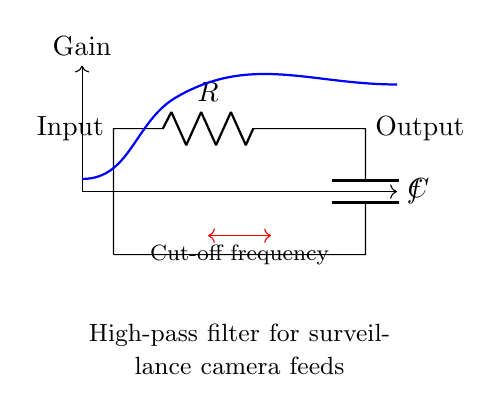What type of filter is represented in the circuit? The circuit diagram clearly indicates that it is a high-pass filter, as indicated by the configuration of the resistor and capacitor. The placement of the capacitor in series with the input signal allows higher frequencies to pass while attenuating lower frequencies.
Answer: high-pass filter What are the components used in the circuit? The components shown in the circuit include a resistor and a capacitor. These are the basic elements that form the high-pass filter. Their labels in the diagram (R for resistor and C for capacitor) provide direct identification.
Answer: resistor and capacitor What is the function of the capacitor in this circuit? The capacitor's function is to block low-frequency signals, allowing high-frequency signals to pass through. This behavior is characteristic of high-pass filters, where the reactance of the capacitor decreases as frequency increases.
Answer: block low-frequency signals What does the cut-off frequency indicate in this circuit? The cut-off frequency indicates the frequency at which the output voltage begins to decrease relative to the input voltage. This point marks the transition from passband to stopband in a high-pass filter.
Answer: frequency transition point In what direction does the current flow in this circuit? The current flows from the input terminal (top) through the resistor, and then into the capacitor before returning to the ground. The diagram shows a single direction of flow from input to output.
Answer: from input to output What would happen if the values of the resistor and capacitor are both increased? Increasing both values would lower the cut-off frequency, reducing the range of frequencies that can pass through the filter. Higher resistor and capacitor values will lead to a slower response to changes in input frequency.
Answer: lower cut-off frequency 